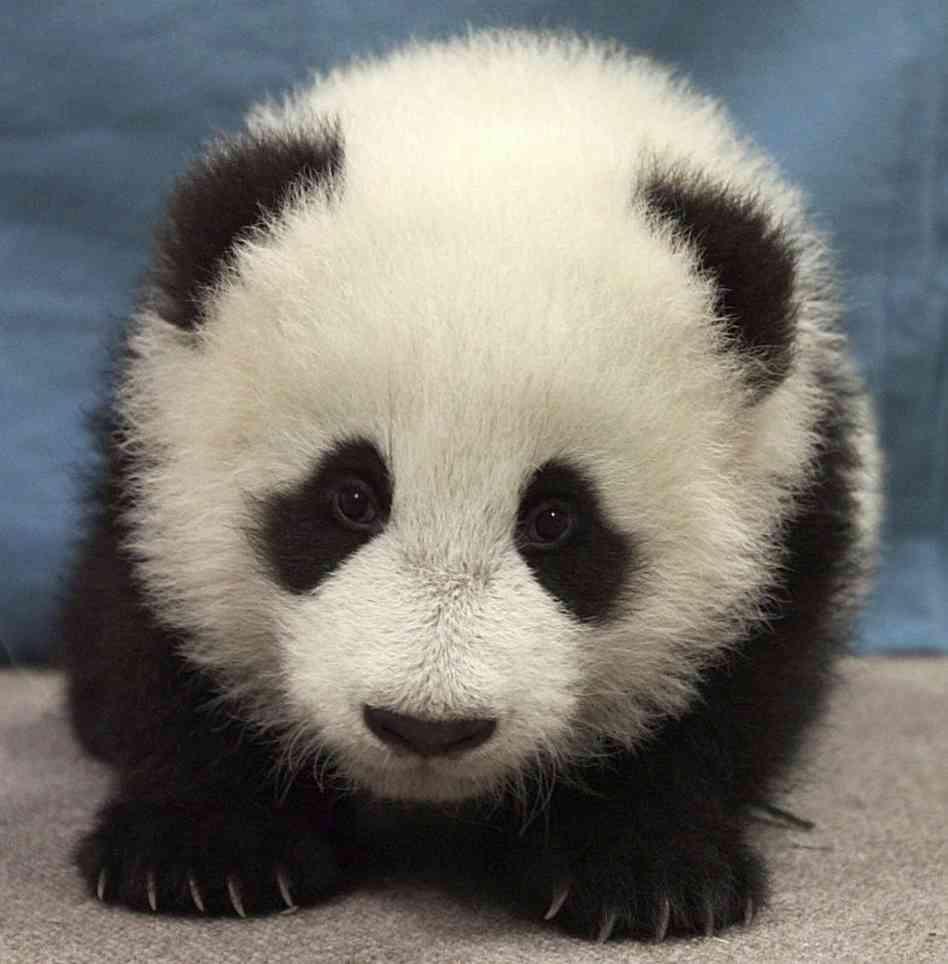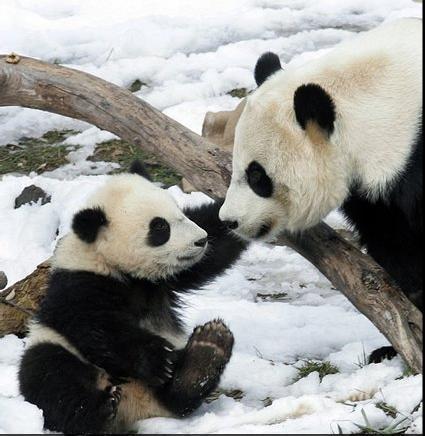The first image is the image on the left, the second image is the image on the right. Given the left and right images, does the statement "In one of the images there is a mother panda with her baby." hold true? Answer yes or no. Yes. The first image is the image on the left, the second image is the image on the right. Given the left and right images, does the statement "There are two panda bears" hold true? Answer yes or no. No. 